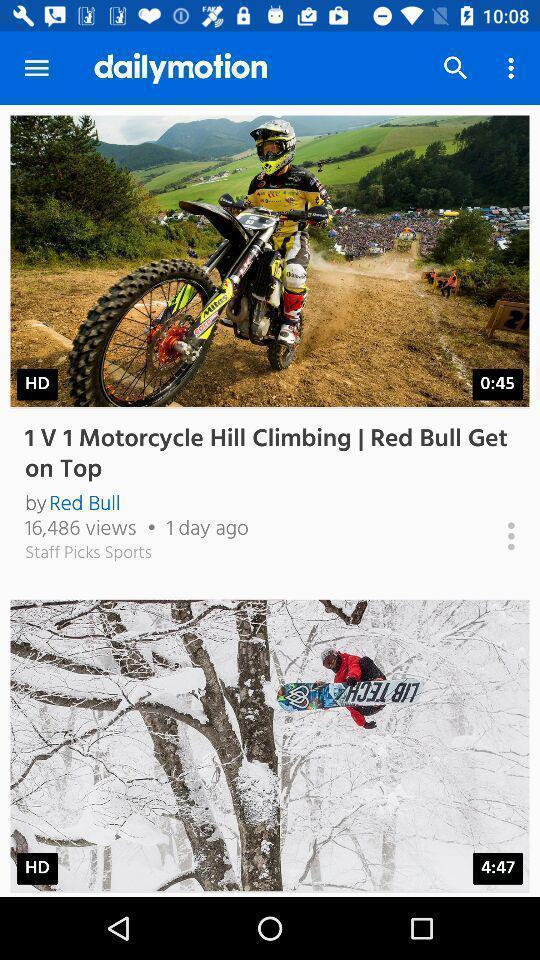Give me a narrative description of this picture. Screen shows multiple videos in a news application. 